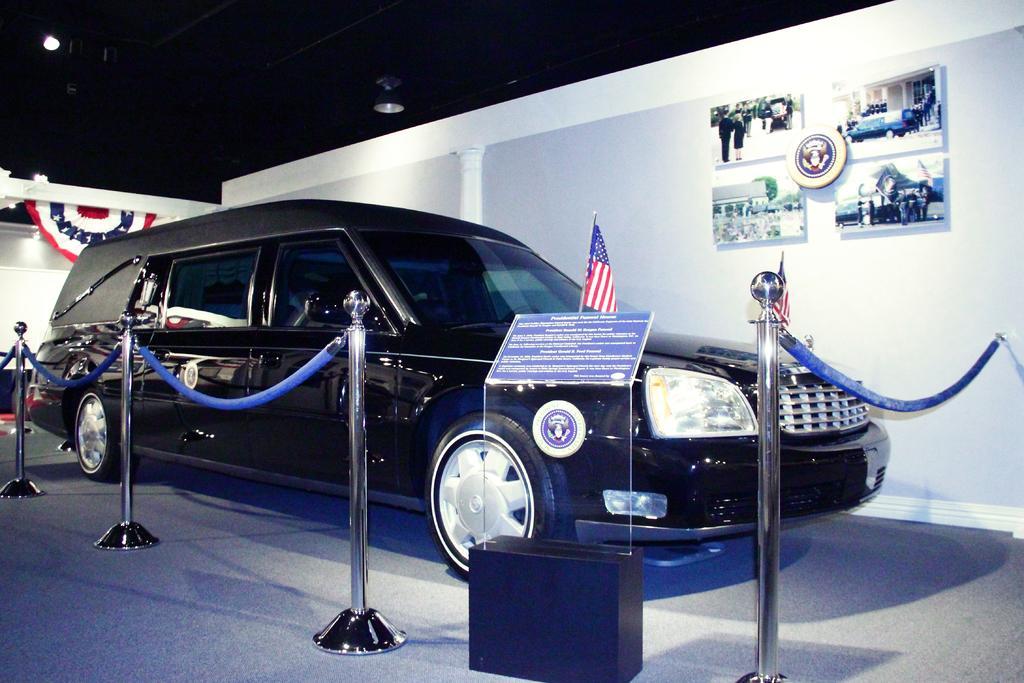In one or two sentences, can you explain what this image depicts? In this image we can see a museum, where a car is displayed which is in black color and which is surrounded by Iron poles and we can also see a american flag and we can see a white wall behind the car and few photographer are displayed to the same wall. 